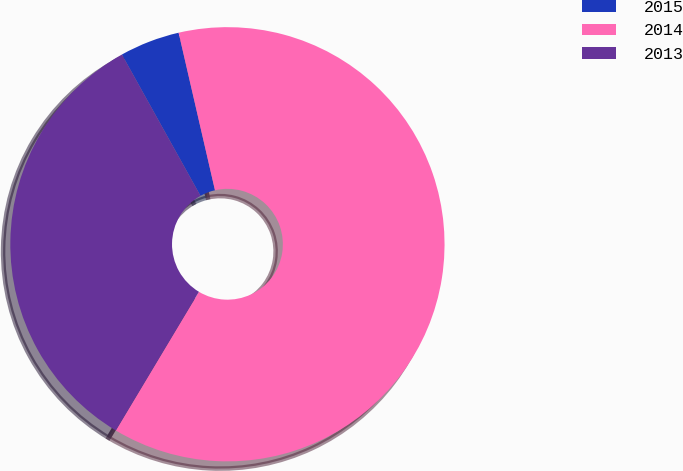Convert chart to OTSL. <chart><loc_0><loc_0><loc_500><loc_500><pie_chart><fcel>2015<fcel>2014<fcel>2013<nl><fcel>4.47%<fcel>62.2%<fcel>33.33%<nl></chart> 